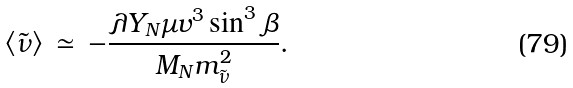Convert formula to latex. <formula><loc_0><loc_0><loc_500><loc_500>\langle \tilde { \nu } \rangle \, \simeq \, - \frac { \lambda Y _ { N } \mu v ^ { 3 } \sin ^ { 3 } \beta } { M _ { N } m _ { \tilde { \nu } } ^ { 2 } } .</formula> 